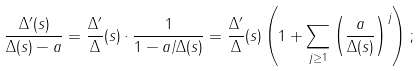Convert formula to latex. <formula><loc_0><loc_0><loc_500><loc_500>\frac { \Delta ^ { \prime } ( s ) } { \Delta ( s ) - a } = \frac { \Delta ^ { \prime } } { \Delta } ( s ) \cdot \frac { 1 } { 1 - a / \Delta ( s ) } = \frac { \Delta ^ { \prime } } { \Delta } ( s ) \left ( 1 + \sum _ { j \geq 1 } \left ( \frac { a } { \Delta ( s ) } \right ) ^ { j } \right ) ;</formula> 